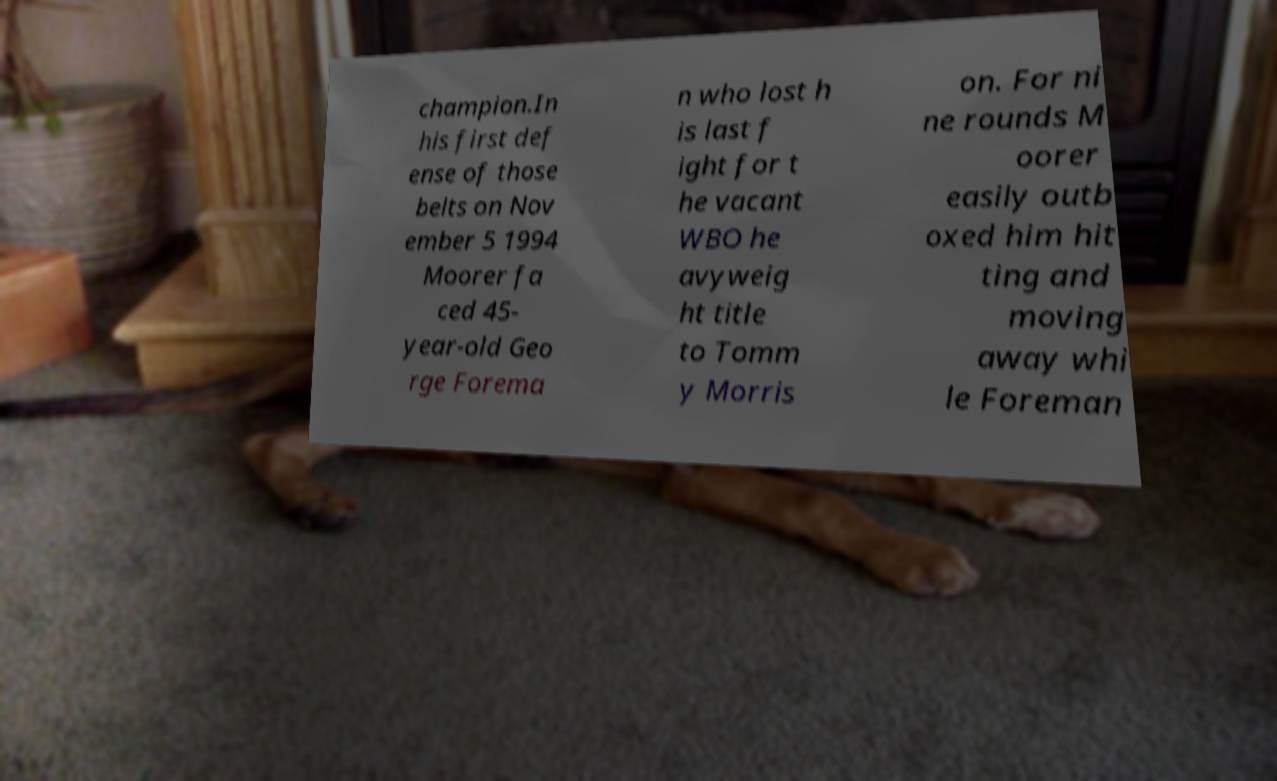There's text embedded in this image that I need extracted. Can you transcribe it verbatim? champion.In his first def ense of those belts on Nov ember 5 1994 Moorer fa ced 45- year-old Geo rge Forema n who lost h is last f ight for t he vacant WBO he avyweig ht title to Tomm y Morris on. For ni ne rounds M oorer easily outb oxed him hit ting and moving away whi le Foreman 